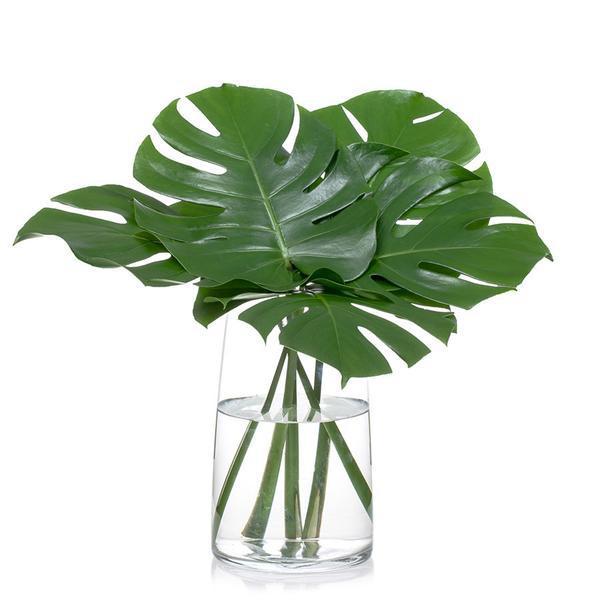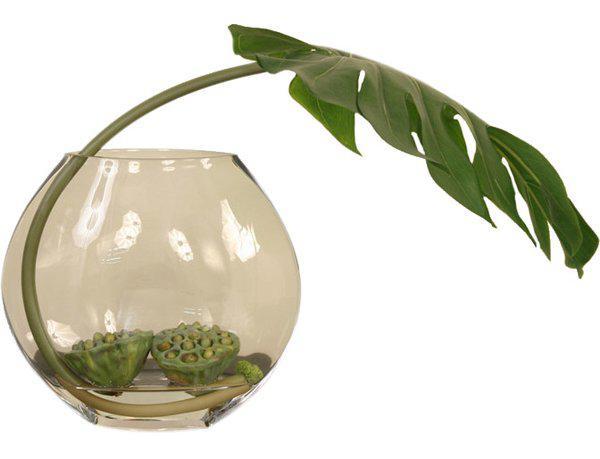The first image is the image on the left, the second image is the image on the right. Examine the images to the left and right. Is the description "In one of the images the plant is in a vase with only water." accurate? Answer yes or no. Yes. The first image is the image on the left, the second image is the image on the right. Considering the images on both sides, is "The left image shows a vase containing only water and multiple leaves, and the right image features a vase with something besides water or a leaf in it." valid? Answer yes or no. Yes. 